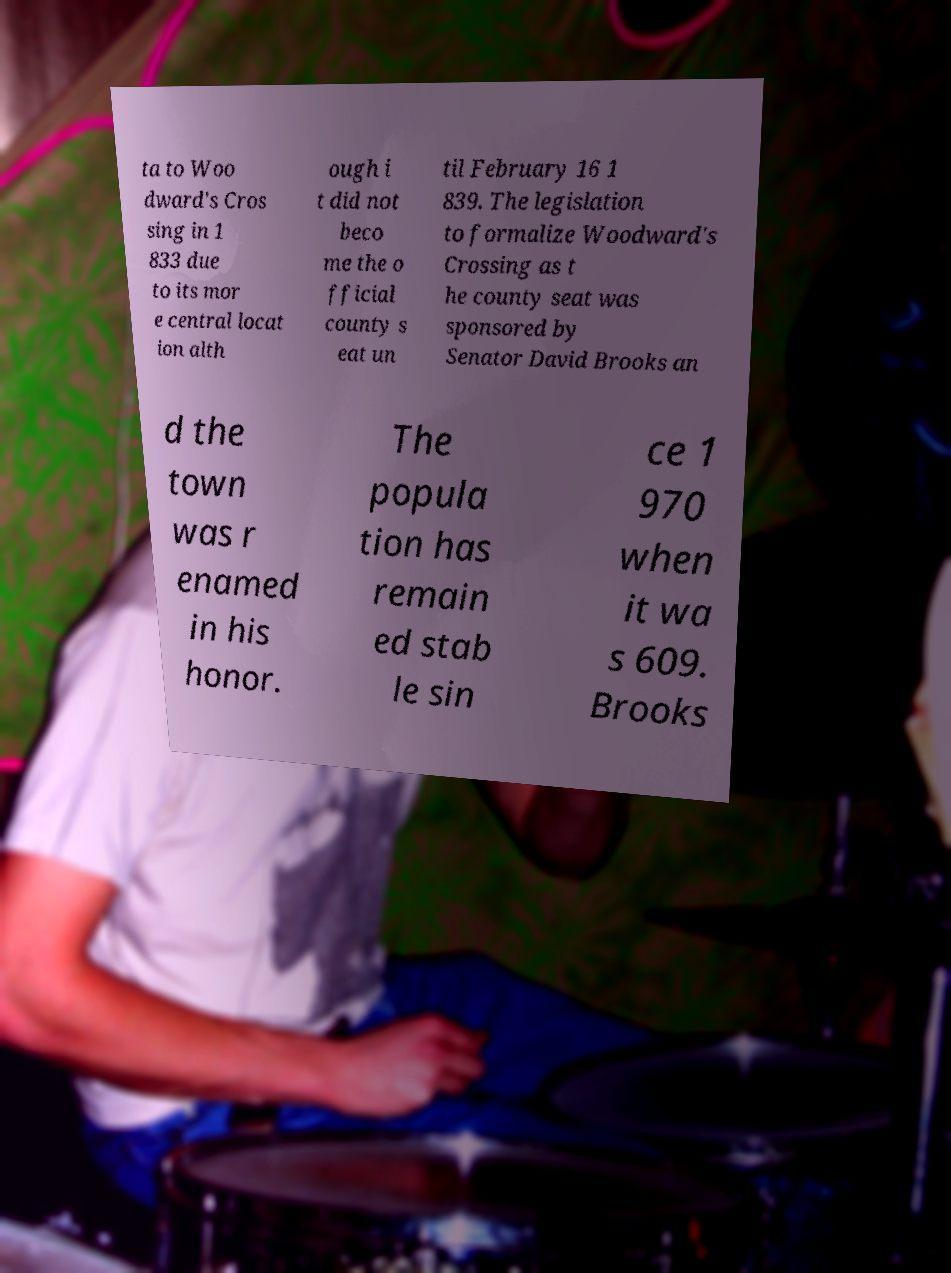I need the written content from this picture converted into text. Can you do that? ta to Woo dward's Cros sing in 1 833 due to its mor e central locat ion alth ough i t did not beco me the o fficial county s eat un til February 16 1 839. The legislation to formalize Woodward's Crossing as t he county seat was sponsored by Senator David Brooks an d the town was r enamed in his honor. The popula tion has remain ed stab le sin ce 1 970 when it wa s 609. Brooks 